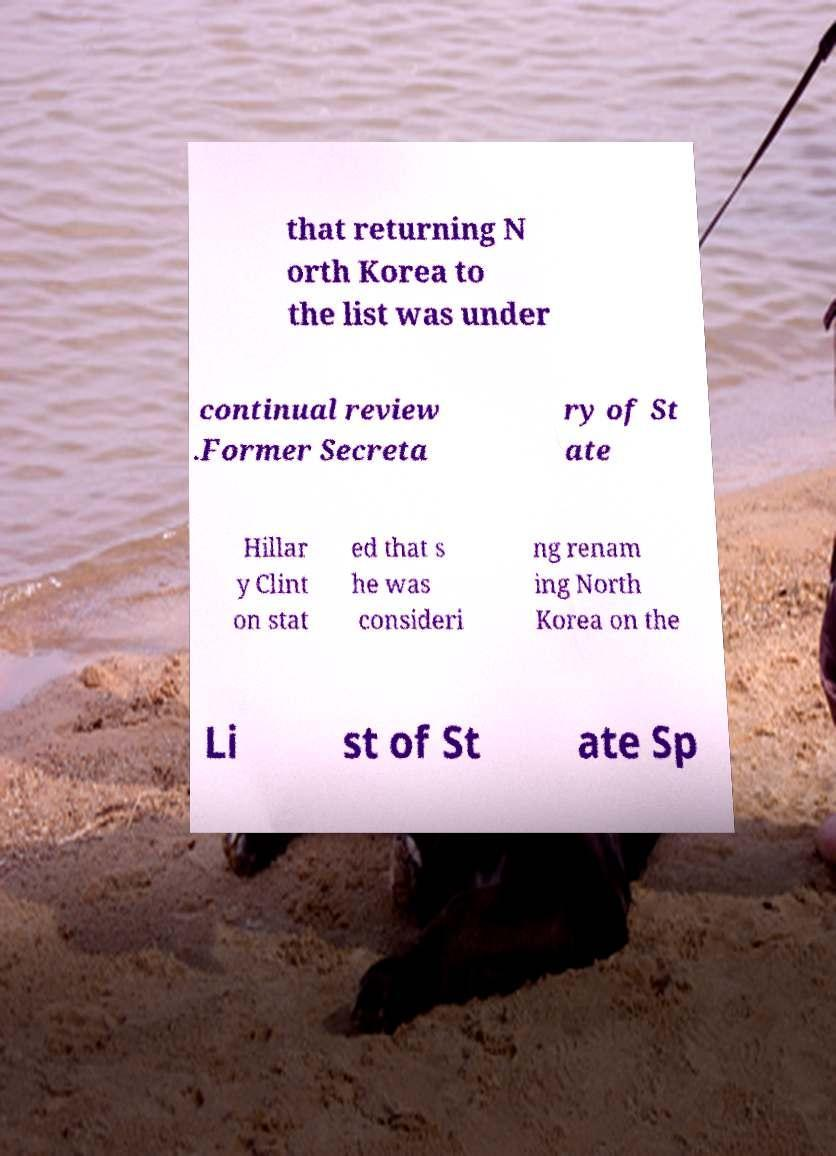Please read and relay the text visible in this image. What does it say? that returning N orth Korea to the list was under continual review .Former Secreta ry of St ate Hillar y Clint on stat ed that s he was consideri ng renam ing North Korea on the Li st of St ate Sp 